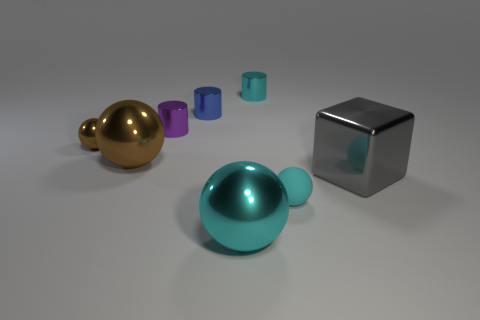Subtract all brown spheres. How many were subtracted if there are1brown spheres left? 1 Subtract all blue cylinders. How many cylinders are left? 2 Subtract all purple cylinders. How many cyan balls are left? 2 Subtract 1 cylinders. How many cylinders are left? 2 Add 1 small blue metallic objects. How many objects exist? 9 Subtract all cylinders. How many objects are left? 5 Subtract all purple balls. Subtract all yellow blocks. How many balls are left? 4 Subtract 0 yellow cylinders. How many objects are left? 8 Subtract all big cyan shiny cylinders. Subtract all small cylinders. How many objects are left? 5 Add 5 small purple things. How many small purple things are left? 6 